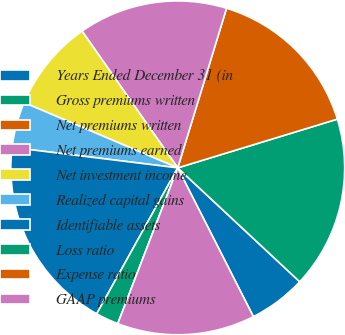Convert chart. <chart><loc_0><loc_0><loc_500><loc_500><pie_chart><fcel>Years Ended December 31 (in<fcel>Gross premiums written<fcel>Net premiums written<fcel>Net premiums earned<fcel>Net investment income<fcel>Realized capital gains<fcel>Identifiable assets<fcel>Loss ratio<fcel>Expense ratio<fcel>GAAP premiums<nl><fcel>5.56%<fcel>16.67%<fcel>15.56%<fcel>14.44%<fcel>8.89%<fcel>4.44%<fcel>18.89%<fcel>2.22%<fcel>0.0%<fcel>13.33%<nl></chart> 